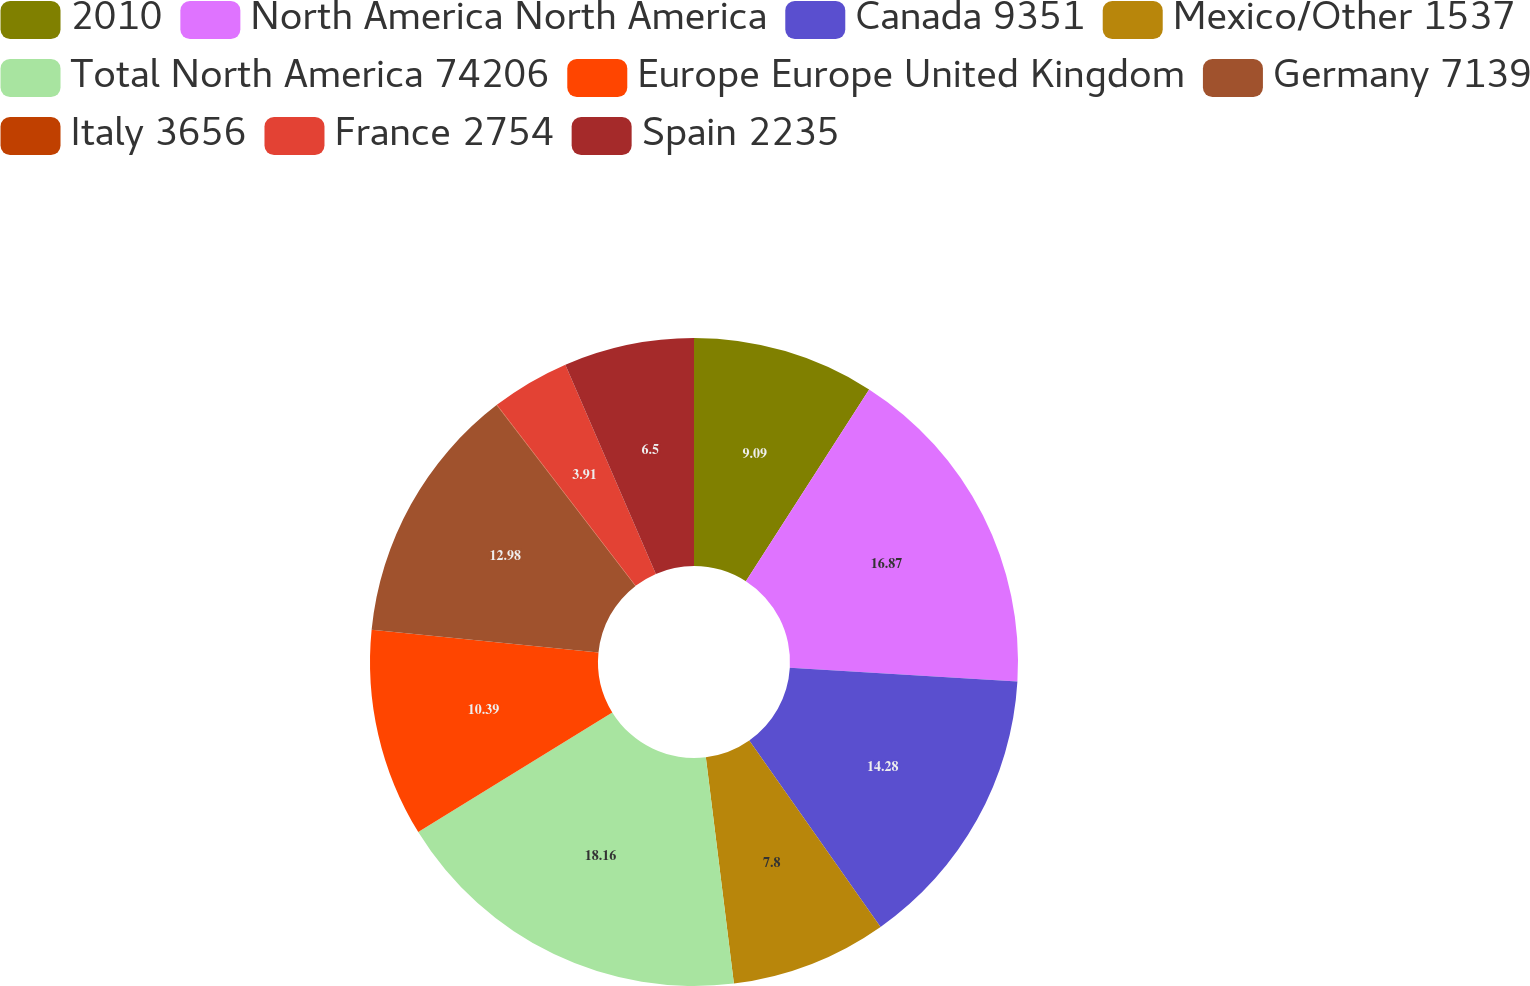Convert chart. <chart><loc_0><loc_0><loc_500><loc_500><pie_chart><fcel>2010<fcel>North America North America<fcel>Canada 9351<fcel>Mexico/Other 1537<fcel>Total North America 74206<fcel>Europe Europe United Kingdom<fcel>Germany 7139<fcel>Italy 3656<fcel>France 2754<fcel>Spain 2235<nl><fcel>9.09%<fcel>16.87%<fcel>14.28%<fcel>7.8%<fcel>18.17%<fcel>10.39%<fcel>12.98%<fcel>0.02%<fcel>3.91%<fcel>6.5%<nl></chart> 